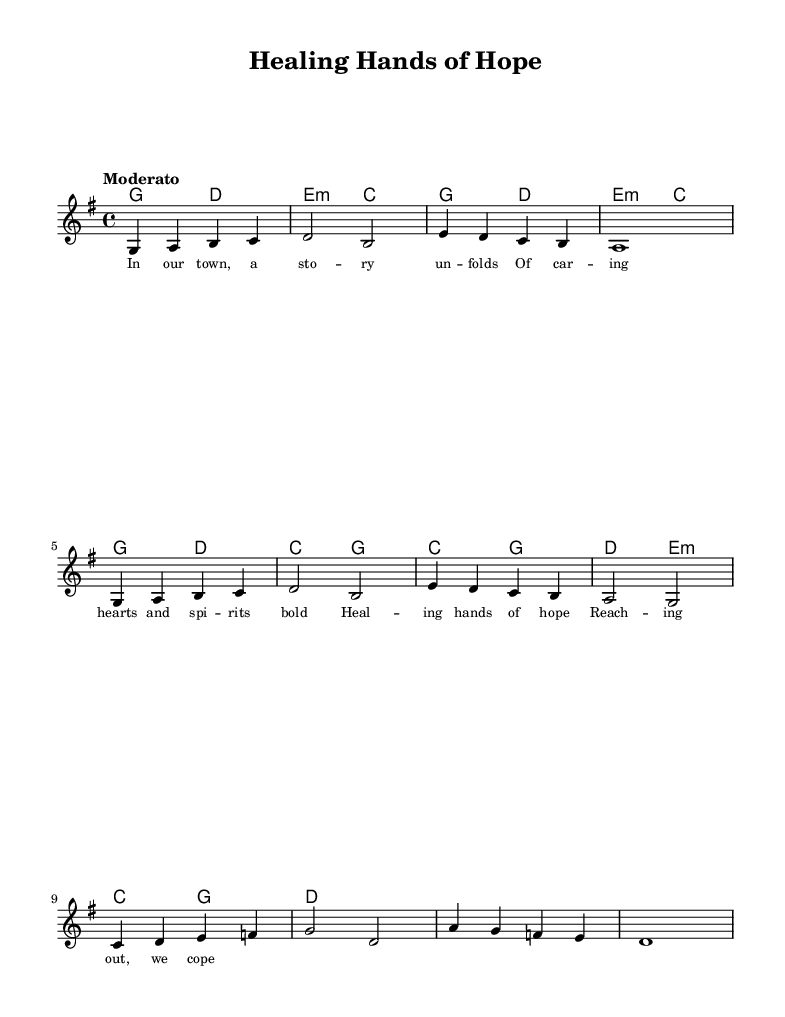What is the key signature of this music? The key signature is G major, which has one sharp (F#). This can be identified by looking at the beginning of the staff where the sharps are indicated.
Answer: G major What is the time signature of this piece? The time signature is 4/4, which means there are four beats in each measure. This is found at the beginning of the sheet music, indicated by the "4/4" notation.
Answer: 4/4 What is the tempo marking of this music? The tempo marking is "Moderato," which suggests a moderate speed of performance. This is usually noted above the staff at the beginning of the piece.
Answer: Moderato How many measures are shown in the melody section? The melody section includes a total of ten measures, which can be counted by identifying the vertical bar lines that separate each measure.
Answer: 10 What is the first lyric of the verse? The first lyric of the verse is "In our town," which can be found under the melody line associated with the first verse in the lyrics section.
Answer: In our town Which chord is used during the chorus? The chord used during the chorus is C major, which is indicated in the chord symbols above the melody. This can be confirmed by the chord names written during the chorus section of the score.
Answer: C major What can you identify as the main theme of the lyrics? The main theme of the lyrics focuses on "healing hands of hope," emphasizing community support and care, as hinted by the lyrics repeated in the chorus section.
Answer: Healing hands of hope 